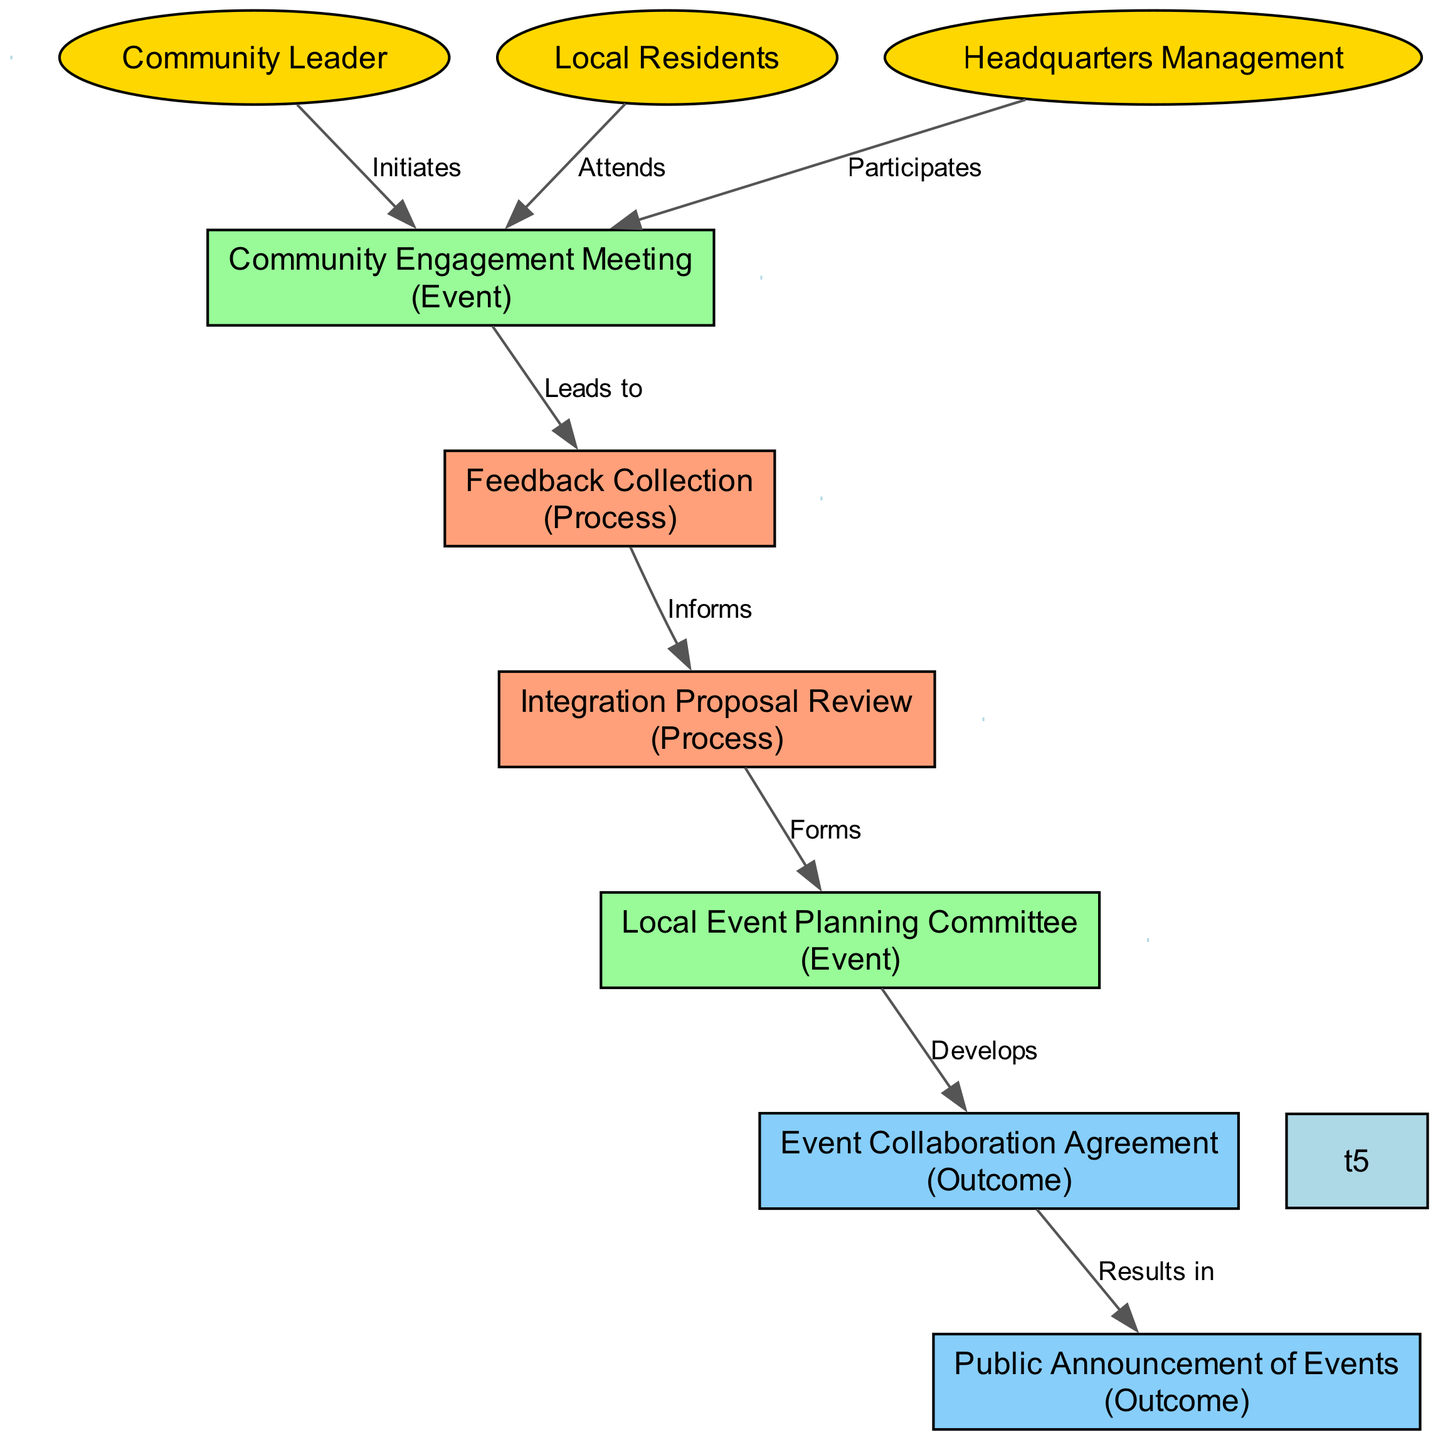What is the first event initiated by the Community Leader? The diagram shows that the first event is the 'Community Engagement Meeting', which is directly initiated by the Community Leader.
Answer: Community Engagement Meeting How many actors are present in the diagram? The diagram contains three actors: Community Leader, Local Residents, and Headquarters Management. By counting them, we find there are three distinct actors.
Answer: 3 What follows the 'Community Engagement Meeting'? After the 'Community Engagement Meeting', the next process indicated in the diagram is 'Feedback Collection', which is shown to lead from the meeting.
Answer: Feedback Collection Who attends the 'Community Engagement Meeting'? The diagram states that 'Local Residents' attend the 'Community Engagement Meeting', as indicated by the edge connecting them.
Answer: Local Residents What is the outcome of the 'Event Collaboration Agreement'? The diagram specifies that the outcome of the 'Event Collaboration Agreement' is the 'Public Announcement of Events', showing their direct connection.
Answer: Public Announcement of Events Which process informs the 'Integration Proposal Review'? The diagram indicates that 'Feedback Collection' informs the 'Integration Proposal Review', as shown by the relationship between these two elements.
Answer: Feedback Collection What is the last event represented in the sequence? The final event in the sequence diagram is the 'Public Announcement of Events', as it is the last outcome listed following the 'Event Collaboration Agreement'.
Answer: Public Announcement of Events How does the Headquarters Management participate in the process? The diagram shows that Headquarters Management participates by attending the 'Community Engagement Meeting', which is their involvement in this engagement process.
Answer: Participates What leads to the 'Integration Proposal Review'? The process that leads to the 'Integration Proposal Review' is 'Feedback Collection', indicating a step where feedback is gathered before reviewing proposals.
Answer: Feedback Collection 